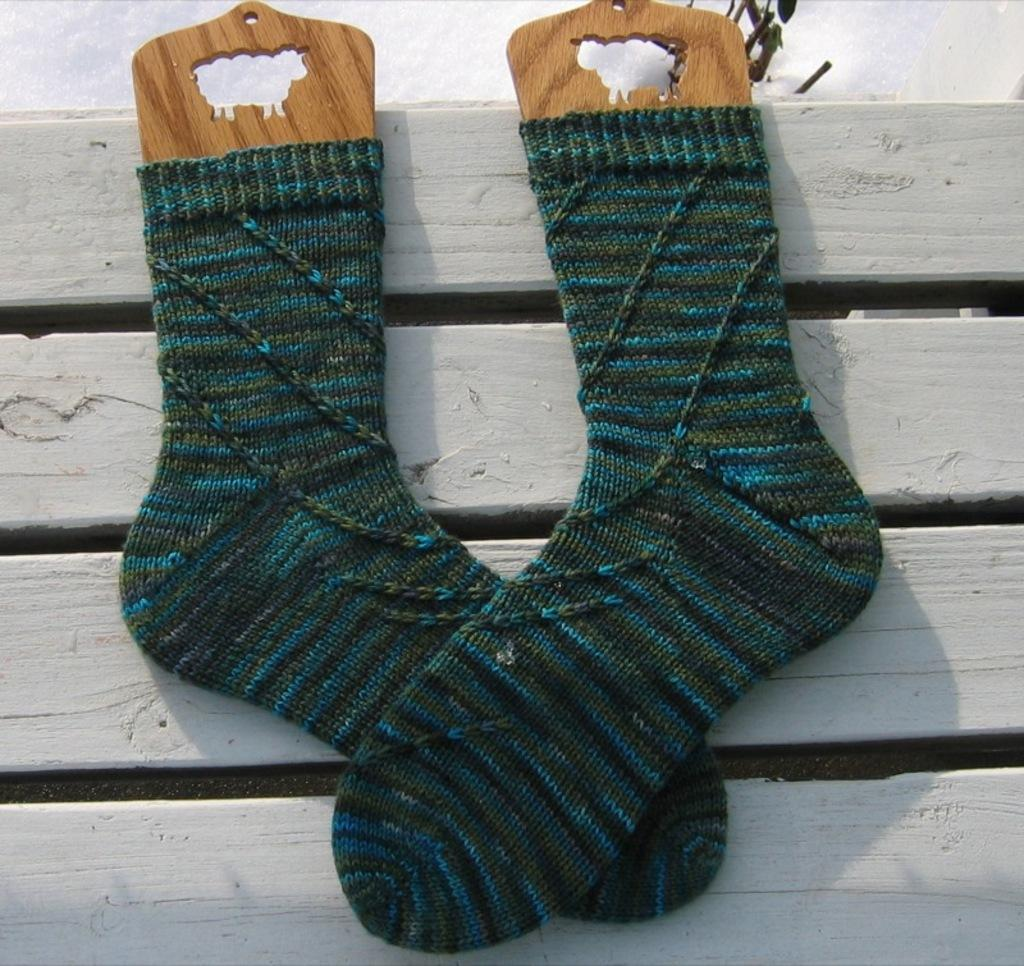What type of clothing item is in the image? There is a pair of socks in the image. On what surface are the socks placed? The socks are placed on a wooden surface. What can be seen in the background of the image? There is a wall in the background of the image. What is the plot of the story unfolding in the image? There is no story or plot depicted in the image; it simply shows a pair of socks on a wooden surface with a wall in the background. 